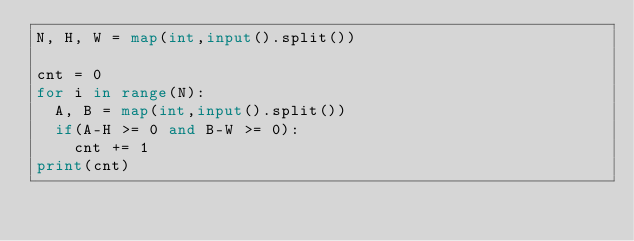<code> <loc_0><loc_0><loc_500><loc_500><_Python_>N, H, W = map(int,input().split())

cnt = 0
for i in range(N):
  A, B = map(int,input().split())
  if(A-H >= 0 and B-W >= 0):
    cnt += 1
print(cnt)</code> 